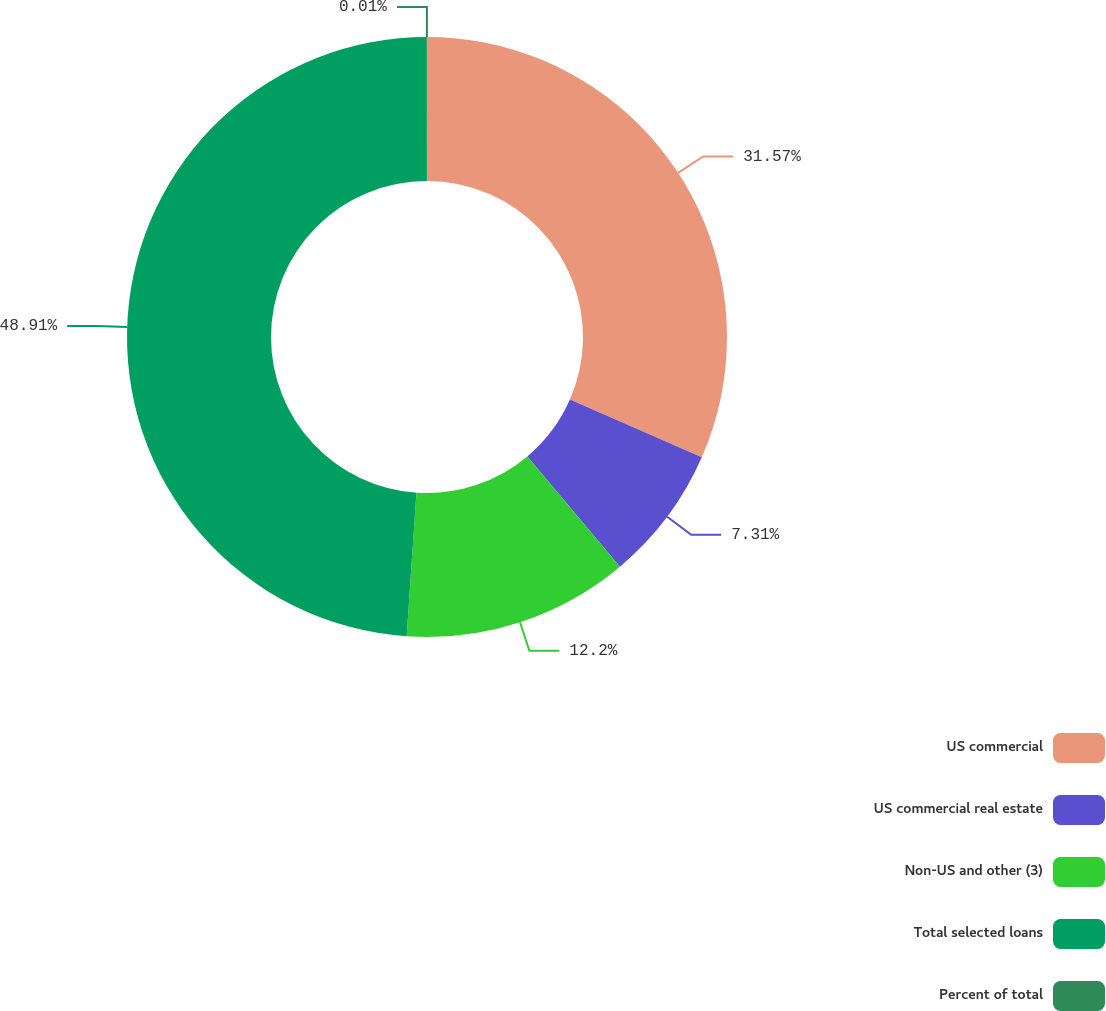<chart> <loc_0><loc_0><loc_500><loc_500><pie_chart><fcel>US commercial<fcel>US commercial real estate<fcel>Non-US and other (3)<fcel>Total selected loans<fcel>Percent of total<nl><fcel>31.57%<fcel>7.31%<fcel>12.2%<fcel>48.91%<fcel>0.01%<nl></chart> 